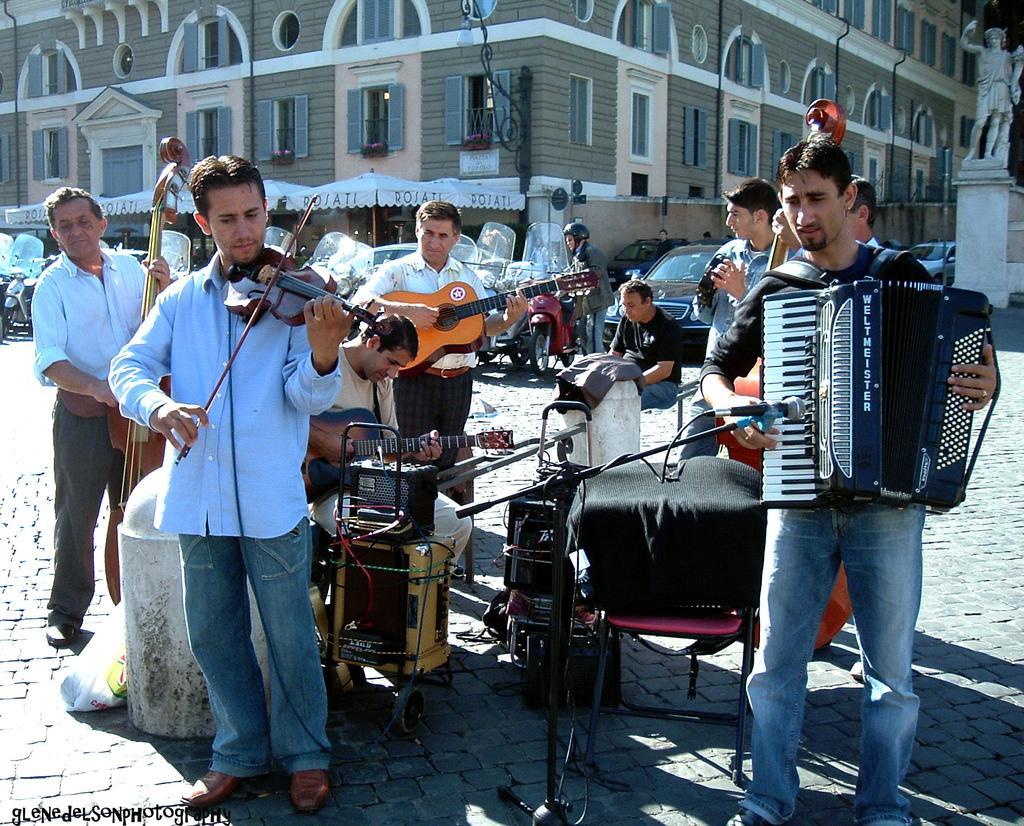Describe this image in one or two sentences. This picture shows there is a music band standing on the road. Everybody is having a musical instrument in his hands and a microphone in front of them and they are playing them. In the background, there are some cars and people walking. We can observe a building here. 